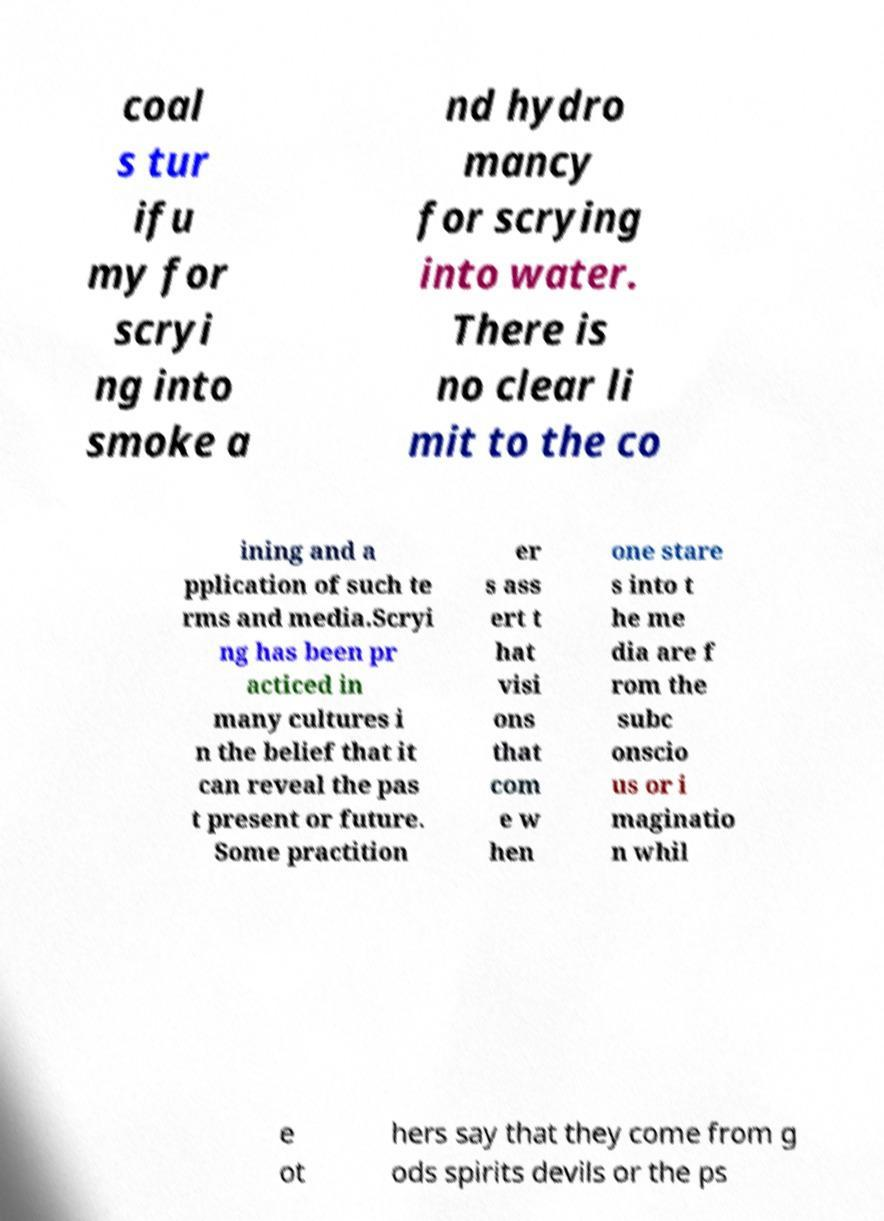I need the written content from this picture converted into text. Can you do that? coal s tur ifu my for scryi ng into smoke a nd hydro mancy for scrying into water. There is no clear li mit to the co ining and a pplication of such te rms and media.Scryi ng has been pr acticed in many cultures i n the belief that it can reveal the pas t present or future. Some practition er s ass ert t hat visi ons that com e w hen one stare s into t he me dia are f rom the subc onscio us or i maginatio n whil e ot hers say that they come from g ods spirits devils or the ps 